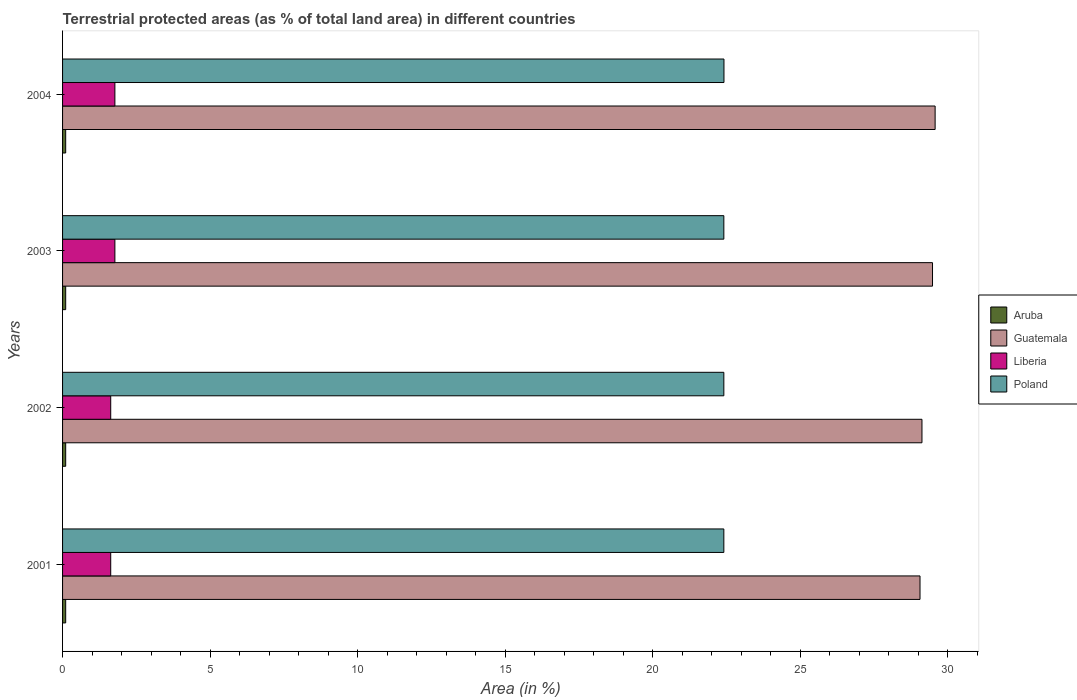How many different coloured bars are there?
Your answer should be very brief. 4. Are the number of bars per tick equal to the number of legend labels?
Ensure brevity in your answer.  Yes. How many bars are there on the 2nd tick from the top?
Keep it short and to the point. 4. What is the percentage of terrestrial protected land in Poland in 2002?
Make the answer very short. 22.41. Across all years, what is the maximum percentage of terrestrial protected land in Liberia?
Your answer should be compact. 1.77. Across all years, what is the minimum percentage of terrestrial protected land in Aruba?
Your answer should be very brief. 0.11. In which year was the percentage of terrestrial protected land in Aruba minimum?
Give a very brief answer. 2001. What is the total percentage of terrestrial protected land in Aruba in the graph?
Your answer should be compact. 0.42. What is the difference between the percentage of terrestrial protected land in Aruba in 2004 and the percentage of terrestrial protected land in Poland in 2001?
Make the answer very short. -22.31. What is the average percentage of terrestrial protected land in Guatemala per year?
Offer a very short reply. 29.31. In the year 2002, what is the difference between the percentage of terrestrial protected land in Aruba and percentage of terrestrial protected land in Guatemala?
Ensure brevity in your answer.  -29.02. In how many years, is the percentage of terrestrial protected land in Poland greater than 5 %?
Make the answer very short. 4. What is the ratio of the percentage of terrestrial protected land in Poland in 2002 to that in 2004?
Make the answer very short. 1. Is the percentage of terrestrial protected land in Poland in 2001 less than that in 2003?
Offer a terse response. No. Is the difference between the percentage of terrestrial protected land in Aruba in 2003 and 2004 greater than the difference between the percentage of terrestrial protected land in Guatemala in 2003 and 2004?
Your answer should be very brief. Yes. What is the difference between the highest and the second highest percentage of terrestrial protected land in Poland?
Offer a very short reply. 0. What is the difference between the highest and the lowest percentage of terrestrial protected land in Guatemala?
Provide a succinct answer. 0.51. In how many years, is the percentage of terrestrial protected land in Guatemala greater than the average percentage of terrestrial protected land in Guatemala taken over all years?
Make the answer very short. 2. Is the sum of the percentage of terrestrial protected land in Aruba in 2001 and 2003 greater than the maximum percentage of terrestrial protected land in Poland across all years?
Your answer should be very brief. No. What does the 2nd bar from the top in 2003 represents?
Keep it short and to the point. Liberia. What does the 3rd bar from the bottom in 2001 represents?
Offer a very short reply. Liberia. Is it the case that in every year, the sum of the percentage of terrestrial protected land in Liberia and percentage of terrestrial protected land in Aruba is greater than the percentage of terrestrial protected land in Poland?
Your response must be concise. No. How many bars are there?
Ensure brevity in your answer.  16. Are all the bars in the graph horizontal?
Make the answer very short. Yes. Does the graph contain any zero values?
Provide a short and direct response. No. Does the graph contain grids?
Provide a succinct answer. No. How are the legend labels stacked?
Your answer should be very brief. Vertical. What is the title of the graph?
Ensure brevity in your answer.  Terrestrial protected areas (as % of total land area) in different countries. Does "Somalia" appear as one of the legend labels in the graph?
Ensure brevity in your answer.  No. What is the label or title of the X-axis?
Your response must be concise. Area (in %). What is the Area (in %) in Aruba in 2001?
Provide a succinct answer. 0.11. What is the Area (in %) in Guatemala in 2001?
Make the answer very short. 29.06. What is the Area (in %) of Liberia in 2001?
Your answer should be very brief. 1.63. What is the Area (in %) in Poland in 2001?
Your answer should be compact. 22.41. What is the Area (in %) of Aruba in 2002?
Provide a succinct answer. 0.11. What is the Area (in %) in Guatemala in 2002?
Give a very brief answer. 29.13. What is the Area (in %) of Liberia in 2002?
Keep it short and to the point. 1.63. What is the Area (in %) of Poland in 2002?
Give a very brief answer. 22.41. What is the Area (in %) in Aruba in 2003?
Give a very brief answer. 0.11. What is the Area (in %) in Guatemala in 2003?
Your response must be concise. 29.49. What is the Area (in %) of Liberia in 2003?
Offer a very short reply. 1.77. What is the Area (in %) in Poland in 2003?
Ensure brevity in your answer.  22.41. What is the Area (in %) in Aruba in 2004?
Your response must be concise. 0.11. What is the Area (in %) of Guatemala in 2004?
Your response must be concise. 29.58. What is the Area (in %) of Liberia in 2004?
Offer a terse response. 1.77. What is the Area (in %) of Poland in 2004?
Keep it short and to the point. 22.42. Across all years, what is the maximum Area (in %) in Aruba?
Give a very brief answer. 0.11. Across all years, what is the maximum Area (in %) in Guatemala?
Provide a succinct answer. 29.58. Across all years, what is the maximum Area (in %) of Liberia?
Provide a short and direct response. 1.77. Across all years, what is the maximum Area (in %) in Poland?
Your response must be concise. 22.42. Across all years, what is the minimum Area (in %) of Aruba?
Make the answer very short. 0.11. Across all years, what is the minimum Area (in %) of Guatemala?
Your response must be concise. 29.06. Across all years, what is the minimum Area (in %) in Liberia?
Provide a short and direct response. 1.63. Across all years, what is the minimum Area (in %) in Poland?
Offer a terse response. 22.41. What is the total Area (in %) in Aruba in the graph?
Give a very brief answer. 0.42. What is the total Area (in %) in Guatemala in the graph?
Provide a succinct answer. 117.26. What is the total Area (in %) in Liberia in the graph?
Your answer should be very brief. 6.81. What is the total Area (in %) in Poland in the graph?
Your response must be concise. 89.66. What is the difference between the Area (in %) in Guatemala in 2001 and that in 2002?
Keep it short and to the point. -0.07. What is the difference between the Area (in %) of Poland in 2001 and that in 2002?
Offer a terse response. 0. What is the difference between the Area (in %) of Aruba in 2001 and that in 2003?
Offer a terse response. 0. What is the difference between the Area (in %) of Guatemala in 2001 and that in 2003?
Give a very brief answer. -0.42. What is the difference between the Area (in %) of Liberia in 2001 and that in 2003?
Provide a short and direct response. -0.14. What is the difference between the Area (in %) in Aruba in 2001 and that in 2004?
Your answer should be compact. 0. What is the difference between the Area (in %) in Guatemala in 2001 and that in 2004?
Your answer should be compact. -0.51. What is the difference between the Area (in %) in Liberia in 2001 and that in 2004?
Your answer should be very brief. -0.14. What is the difference between the Area (in %) in Poland in 2001 and that in 2004?
Offer a terse response. -0. What is the difference between the Area (in %) of Aruba in 2002 and that in 2003?
Give a very brief answer. 0. What is the difference between the Area (in %) of Guatemala in 2002 and that in 2003?
Your answer should be very brief. -0.36. What is the difference between the Area (in %) of Liberia in 2002 and that in 2003?
Keep it short and to the point. -0.14. What is the difference between the Area (in %) of Aruba in 2002 and that in 2004?
Offer a terse response. 0. What is the difference between the Area (in %) in Guatemala in 2002 and that in 2004?
Give a very brief answer. -0.45. What is the difference between the Area (in %) of Liberia in 2002 and that in 2004?
Give a very brief answer. -0.14. What is the difference between the Area (in %) of Poland in 2002 and that in 2004?
Your answer should be compact. -0. What is the difference between the Area (in %) of Guatemala in 2003 and that in 2004?
Your answer should be very brief. -0.09. What is the difference between the Area (in %) of Poland in 2003 and that in 2004?
Offer a terse response. -0. What is the difference between the Area (in %) in Aruba in 2001 and the Area (in %) in Guatemala in 2002?
Your answer should be very brief. -29.02. What is the difference between the Area (in %) in Aruba in 2001 and the Area (in %) in Liberia in 2002?
Offer a very short reply. -1.53. What is the difference between the Area (in %) in Aruba in 2001 and the Area (in %) in Poland in 2002?
Your answer should be very brief. -22.31. What is the difference between the Area (in %) of Guatemala in 2001 and the Area (in %) of Liberia in 2002?
Provide a short and direct response. 27.43. What is the difference between the Area (in %) in Guatemala in 2001 and the Area (in %) in Poland in 2002?
Ensure brevity in your answer.  6.65. What is the difference between the Area (in %) of Liberia in 2001 and the Area (in %) of Poland in 2002?
Offer a terse response. -20.78. What is the difference between the Area (in %) in Aruba in 2001 and the Area (in %) in Guatemala in 2003?
Make the answer very short. -29.38. What is the difference between the Area (in %) of Aruba in 2001 and the Area (in %) of Liberia in 2003?
Your response must be concise. -1.67. What is the difference between the Area (in %) in Aruba in 2001 and the Area (in %) in Poland in 2003?
Offer a very short reply. -22.31. What is the difference between the Area (in %) of Guatemala in 2001 and the Area (in %) of Liberia in 2003?
Provide a succinct answer. 27.29. What is the difference between the Area (in %) in Guatemala in 2001 and the Area (in %) in Poland in 2003?
Keep it short and to the point. 6.65. What is the difference between the Area (in %) in Liberia in 2001 and the Area (in %) in Poland in 2003?
Provide a succinct answer. -20.78. What is the difference between the Area (in %) in Aruba in 2001 and the Area (in %) in Guatemala in 2004?
Your response must be concise. -29.47. What is the difference between the Area (in %) in Aruba in 2001 and the Area (in %) in Liberia in 2004?
Your answer should be compact. -1.67. What is the difference between the Area (in %) of Aruba in 2001 and the Area (in %) of Poland in 2004?
Offer a very short reply. -22.31. What is the difference between the Area (in %) in Guatemala in 2001 and the Area (in %) in Liberia in 2004?
Provide a succinct answer. 27.29. What is the difference between the Area (in %) in Guatemala in 2001 and the Area (in %) in Poland in 2004?
Make the answer very short. 6.64. What is the difference between the Area (in %) in Liberia in 2001 and the Area (in %) in Poland in 2004?
Offer a terse response. -20.79. What is the difference between the Area (in %) in Aruba in 2002 and the Area (in %) in Guatemala in 2003?
Ensure brevity in your answer.  -29.38. What is the difference between the Area (in %) of Aruba in 2002 and the Area (in %) of Liberia in 2003?
Provide a succinct answer. -1.67. What is the difference between the Area (in %) in Aruba in 2002 and the Area (in %) in Poland in 2003?
Provide a short and direct response. -22.31. What is the difference between the Area (in %) of Guatemala in 2002 and the Area (in %) of Liberia in 2003?
Provide a succinct answer. 27.36. What is the difference between the Area (in %) in Guatemala in 2002 and the Area (in %) in Poland in 2003?
Your answer should be compact. 6.72. What is the difference between the Area (in %) of Liberia in 2002 and the Area (in %) of Poland in 2003?
Ensure brevity in your answer.  -20.78. What is the difference between the Area (in %) of Aruba in 2002 and the Area (in %) of Guatemala in 2004?
Ensure brevity in your answer.  -29.47. What is the difference between the Area (in %) in Aruba in 2002 and the Area (in %) in Liberia in 2004?
Make the answer very short. -1.67. What is the difference between the Area (in %) in Aruba in 2002 and the Area (in %) in Poland in 2004?
Ensure brevity in your answer.  -22.31. What is the difference between the Area (in %) of Guatemala in 2002 and the Area (in %) of Liberia in 2004?
Offer a very short reply. 27.36. What is the difference between the Area (in %) in Guatemala in 2002 and the Area (in %) in Poland in 2004?
Make the answer very short. 6.71. What is the difference between the Area (in %) in Liberia in 2002 and the Area (in %) in Poland in 2004?
Offer a terse response. -20.79. What is the difference between the Area (in %) of Aruba in 2003 and the Area (in %) of Guatemala in 2004?
Offer a very short reply. -29.47. What is the difference between the Area (in %) in Aruba in 2003 and the Area (in %) in Liberia in 2004?
Offer a terse response. -1.67. What is the difference between the Area (in %) of Aruba in 2003 and the Area (in %) of Poland in 2004?
Provide a succinct answer. -22.31. What is the difference between the Area (in %) of Guatemala in 2003 and the Area (in %) of Liberia in 2004?
Make the answer very short. 27.71. What is the difference between the Area (in %) in Guatemala in 2003 and the Area (in %) in Poland in 2004?
Your answer should be compact. 7.07. What is the difference between the Area (in %) of Liberia in 2003 and the Area (in %) of Poland in 2004?
Make the answer very short. -20.65. What is the average Area (in %) in Aruba per year?
Keep it short and to the point. 0.11. What is the average Area (in %) in Guatemala per year?
Ensure brevity in your answer.  29.31. What is the average Area (in %) of Liberia per year?
Your response must be concise. 1.7. What is the average Area (in %) of Poland per year?
Ensure brevity in your answer.  22.42. In the year 2001, what is the difference between the Area (in %) of Aruba and Area (in %) of Guatemala?
Your answer should be compact. -28.96. In the year 2001, what is the difference between the Area (in %) of Aruba and Area (in %) of Liberia?
Provide a short and direct response. -1.53. In the year 2001, what is the difference between the Area (in %) in Aruba and Area (in %) in Poland?
Make the answer very short. -22.31. In the year 2001, what is the difference between the Area (in %) in Guatemala and Area (in %) in Liberia?
Provide a short and direct response. 27.43. In the year 2001, what is the difference between the Area (in %) of Guatemala and Area (in %) of Poland?
Provide a short and direct response. 6.65. In the year 2001, what is the difference between the Area (in %) of Liberia and Area (in %) of Poland?
Keep it short and to the point. -20.78. In the year 2002, what is the difference between the Area (in %) in Aruba and Area (in %) in Guatemala?
Your response must be concise. -29.02. In the year 2002, what is the difference between the Area (in %) of Aruba and Area (in %) of Liberia?
Your response must be concise. -1.53. In the year 2002, what is the difference between the Area (in %) of Aruba and Area (in %) of Poland?
Ensure brevity in your answer.  -22.31. In the year 2002, what is the difference between the Area (in %) in Guatemala and Area (in %) in Liberia?
Your response must be concise. 27.5. In the year 2002, what is the difference between the Area (in %) of Guatemala and Area (in %) of Poland?
Make the answer very short. 6.72. In the year 2002, what is the difference between the Area (in %) in Liberia and Area (in %) in Poland?
Offer a very short reply. -20.78. In the year 2003, what is the difference between the Area (in %) in Aruba and Area (in %) in Guatemala?
Your answer should be very brief. -29.38. In the year 2003, what is the difference between the Area (in %) of Aruba and Area (in %) of Liberia?
Your response must be concise. -1.67. In the year 2003, what is the difference between the Area (in %) of Aruba and Area (in %) of Poland?
Your answer should be compact. -22.31. In the year 2003, what is the difference between the Area (in %) in Guatemala and Area (in %) in Liberia?
Your answer should be very brief. 27.71. In the year 2003, what is the difference between the Area (in %) in Guatemala and Area (in %) in Poland?
Keep it short and to the point. 7.07. In the year 2003, what is the difference between the Area (in %) of Liberia and Area (in %) of Poland?
Make the answer very short. -20.64. In the year 2004, what is the difference between the Area (in %) of Aruba and Area (in %) of Guatemala?
Your answer should be very brief. -29.47. In the year 2004, what is the difference between the Area (in %) of Aruba and Area (in %) of Liberia?
Provide a succinct answer. -1.67. In the year 2004, what is the difference between the Area (in %) of Aruba and Area (in %) of Poland?
Keep it short and to the point. -22.31. In the year 2004, what is the difference between the Area (in %) of Guatemala and Area (in %) of Liberia?
Your answer should be very brief. 27.8. In the year 2004, what is the difference between the Area (in %) of Guatemala and Area (in %) of Poland?
Your answer should be compact. 7.16. In the year 2004, what is the difference between the Area (in %) of Liberia and Area (in %) of Poland?
Give a very brief answer. -20.65. What is the ratio of the Area (in %) in Aruba in 2001 to that in 2002?
Offer a very short reply. 1. What is the ratio of the Area (in %) in Guatemala in 2001 to that in 2002?
Offer a terse response. 1. What is the ratio of the Area (in %) of Liberia in 2001 to that in 2002?
Keep it short and to the point. 1. What is the ratio of the Area (in %) in Guatemala in 2001 to that in 2003?
Your answer should be compact. 0.99. What is the ratio of the Area (in %) of Liberia in 2001 to that in 2003?
Ensure brevity in your answer.  0.92. What is the ratio of the Area (in %) in Poland in 2001 to that in 2003?
Offer a terse response. 1. What is the ratio of the Area (in %) in Aruba in 2001 to that in 2004?
Provide a succinct answer. 1. What is the ratio of the Area (in %) of Guatemala in 2001 to that in 2004?
Give a very brief answer. 0.98. What is the ratio of the Area (in %) of Liberia in 2001 to that in 2004?
Your response must be concise. 0.92. What is the ratio of the Area (in %) in Poland in 2001 to that in 2004?
Make the answer very short. 1. What is the ratio of the Area (in %) in Guatemala in 2002 to that in 2003?
Your answer should be very brief. 0.99. What is the ratio of the Area (in %) in Liberia in 2002 to that in 2003?
Give a very brief answer. 0.92. What is the ratio of the Area (in %) in Poland in 2002 to that in 2003?
Offer a very short reply. 1. What is the ratio of the Area (in %) in Guatemala in 2002 to that in 2004?
Give a very brief answer. 0.98. What is the ratio of the Area (in %) of Liberia in 2002 to that in 2004?
Your answer should be very brief. 0.92. What is the ratio of the Area (in %) of Poland in 2002 to that in 2004?
Make the answer very short. 1. What is the ratio of the Area (in %) of Aruba in 2003 to that in 2004?
Your answer should be compact. 1. What is the difference between the highest and the second highest Area (in %) in Guatemala?
Offer a terse response. 0.09. What is the difference between the highest and the second highest Area (in %) in Liberia?
Offer a terse response. 0. What is the difference between the highest and the second highest Area (in %) in Poland?
Keep it short and to the point. 0. What is the difference between the highest and the lowest Area (in %) of Guatemala?
Your answer should be compact. 0.51. What is the difference between the highest and the lowest Area (in %) of Liberia?
Keep it short and to the point. 0.14. What is the difference between the highest and the lowest Area (in %) in Poland?
Your answer should be compact. 0. 